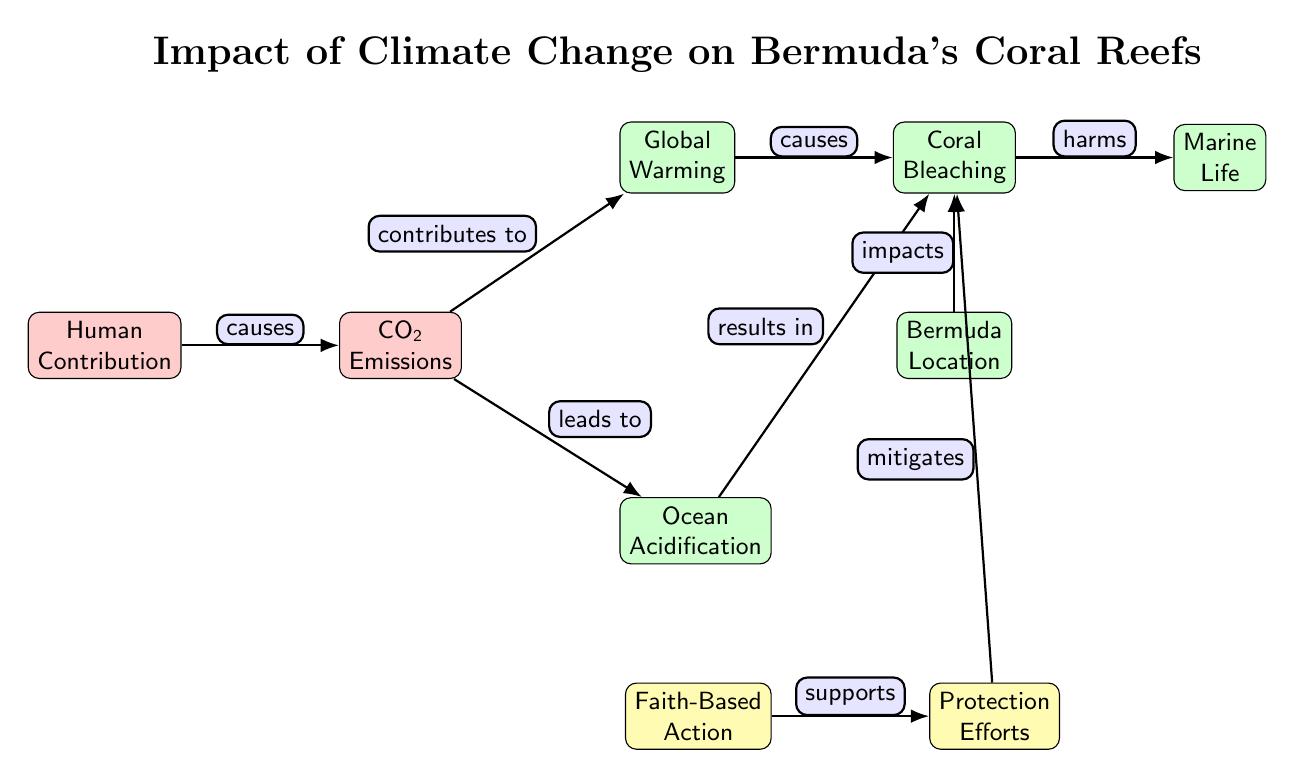What is the first node in the diagram? The first node in the diagram, indicating the starting point of the flow, is "Human Contribution." This node is centrally placed and connects to the subsequent nodes about climate change impacts.
Answer: Human Contribution How many nodes are there in total in the diagram? By counting all the distinct nodes, there are eight nodes in total: Human Contribution, CO2 Emissions, Global Warming, Ocean Acidification, Coral Bleaching, Marine Life, Bermuda Location, and Protection Efforts.
Answer: Eight What does CO2 Emissions contribute to? The node labeled "CO2 Emissions" has arrows pointing to both "Global Warming" and "Ocean Acidification," indicating that it contributes to both of these issues.
Answer: Global Warming and Ocean Acidification Which node directly impacts Coral Bleaching? The arrows leading into "Coral Bleaching" are from "Global Warming" and "Ocean Acidification," meaning these two nodes directly impact it. Additionally, "Bermuda Location" also has an arrow pointing toward "Coral Bleaching," indicating a local impact as well.
Answer: Global Warming, Ocean Acidification, Bermuda Location What role does Faith-Based Action play in the diagram? "Faith-Based Action" supports "Protection Efforts," which in turn mitigates the impact on "Coral Bleaching." This shows the role of faith in contributing to coral protection efforts.
Answer: Supports Protection Efforts How does Ocean Acidification relate to Coral Bleaching? Ocean Acidification has a direct arrow that indicates it "results in" Coral Bleaching, showing a causal relationship where acidification contributes to bleaching effects.
Answer: Results in What is the relationship between Coral Bleaching and Marine Life? The arrow from "Coral Bleaching" to "Marine Life" indicates that coral bleaching harms marine life, highlighting the negative effects of bleaching on overall marine ecosystems.
Answer: Harms What mitigates Coral Bleaching in the diagram? The node "Protection Efforts" is indicated to "mitigate" Coral Bleaching, suggesting it acts to reduce or lessen the bleaching processes.
Answer: Mitigates Which factors lead to the processes affecting Bermuda's coral reefs? The diagram shows CO2 Emissions leading to two main factors: Global Warming and Ocean Acidification, both of which further lead to Coral Bleaching affecting Bermuda's reefs. This illustrates a path of human impact through climate change to coral reef degradation.
Answer: CO2 Emissions, Global Warming, Ocean Acidification 